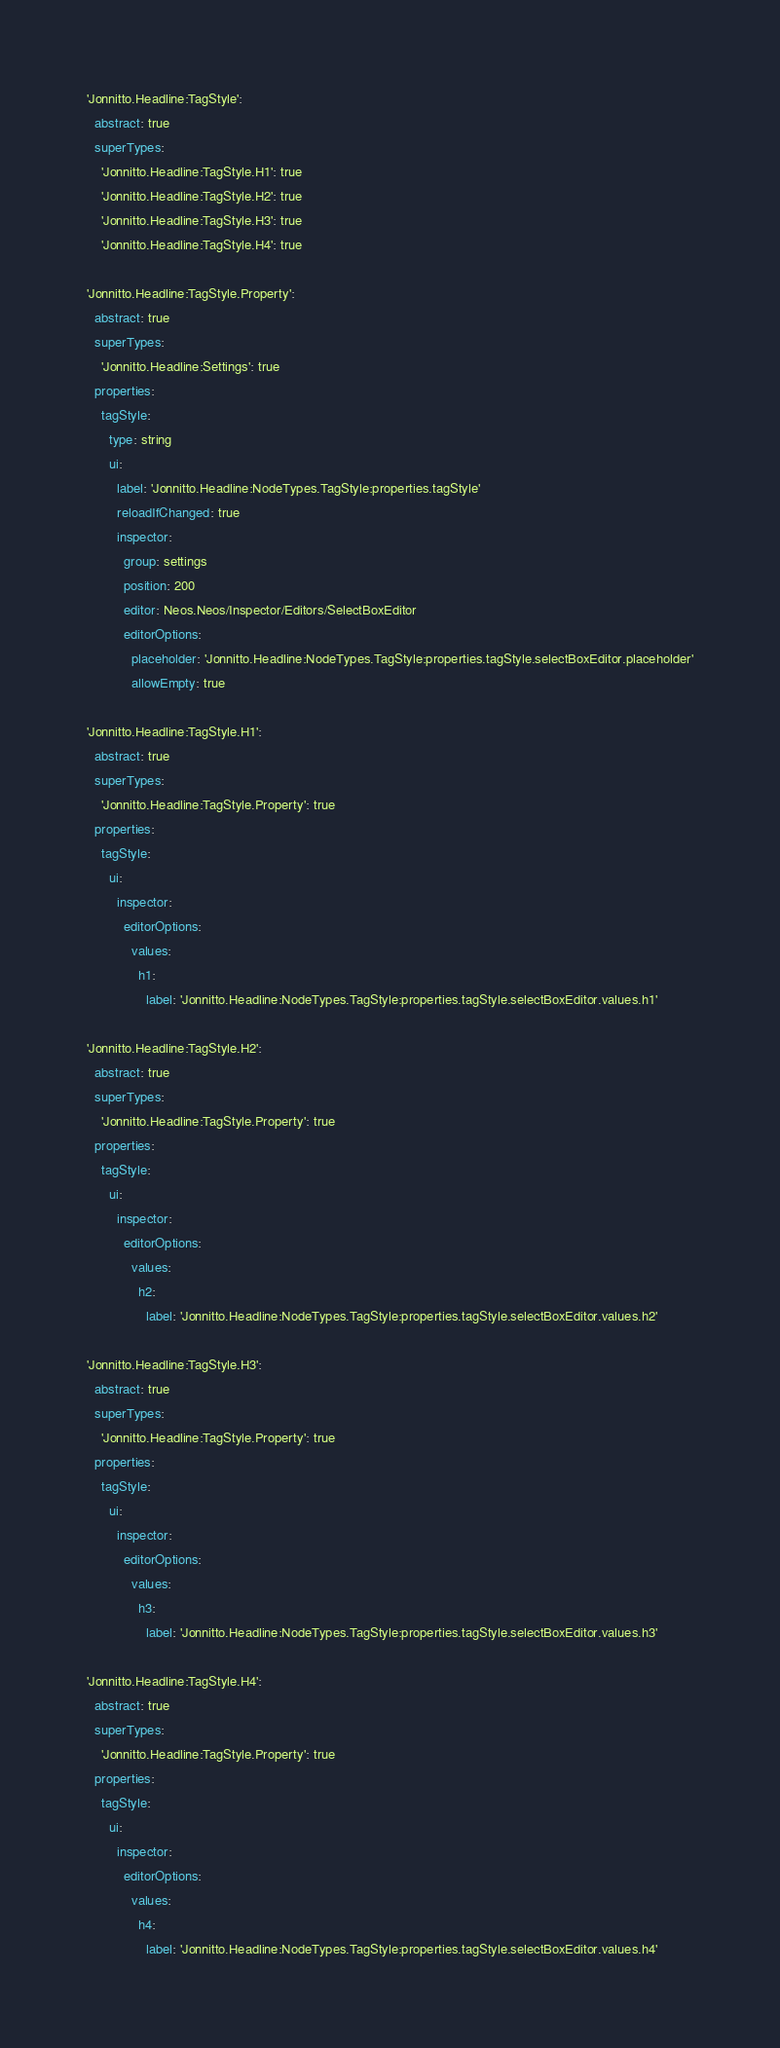<code> <loc_0><loc_0><loc_500><loc_500><_YAML_>'Jonnitto.Headline:TagStyle':
  abstract: true
  superTypes:
    'Jonnitto.Headline:TagStyle.H1': true
    'Jonnitto.Headline:TagStyle.H2': true
    'Jonnitto.Headline:TagStyle.H3': true
    'Jonnitto.Headline:TagStyle.H4': true

'Jonnitto.Headline:TagStyle.Property':
  abstract: true
  superTypes:
    'Jonnitto.Headline:Settings': true
  properties:
    tagStyle:
      type: string
      ui:
        label: 'Jonnitto.Headline:NodeTypes.TagStyle:properties.tagStyle'
        reloadIfChanged: true
        inspector:
          group: settings
          position: 200
          editor: Neos.Neos/Inspector/Editors/SelectBoxEditor
          editorOptions:
            placeholder: 'Jonnitto.Headline:NodeTypes.TagStyle:properties.tagStyle.selectBoxEditor.placeholder'
            allowEmpty: true

'Jonnitto.Headline:TagStyle.H1':
  abstract: true
  superTypes:
    'Jonnitto.Headline:TagStyle.Property': true
  properties:
    tagStyle:
      ui:
        inspector:
          editorOptions:
            values:
              h1:
                label: 'Jonnitto.Headline:NodeTypes.TagStyle:properties.tagStyle.selectBoxEditor.values.h1'

'Jonnitto.Headline:TagStyle.H2':
  abstract: true
  superTypes:
    'Jonnitto.Headline:TagStyle.Property': true
  properties:
    tagStyle:
      ui:
        inspector:
          editorOptions:
            values:
              h2:
                label: 'Jonnitto.Headline:NodeTypes.TagStyle:properties.tagStyle.selectBoxEditor.values.h2'

'Jonnitto.Headline:TagStyle.H3':
  abstract: true
  superTypes:
    'Jonnitto.Headline:TagStyle.Property': true
  properties:
    tagStyle:
      ui:
        inspector:
          editorOptions:
            values:
              h3:
                label: 'Jonnitto.Headline:NodeTypes.TagStyle:properties.tagStyle.selectBoxEditor.values.h3'

'Jonnitto.Headline:TagStyle.H4':
  abstract: true
  superTypes:
    'Jonnitto.Headline:TagStyle.Property': true
  properties:
    tagStyle:
      ui:
        inspector:
          editorOptions:
            values:
              h4:
                label: 'Jonnitto.Headline:NodeTypes.TagStyle:properties.tagStyle.selectBoxEditor.values.h4'
</code> 